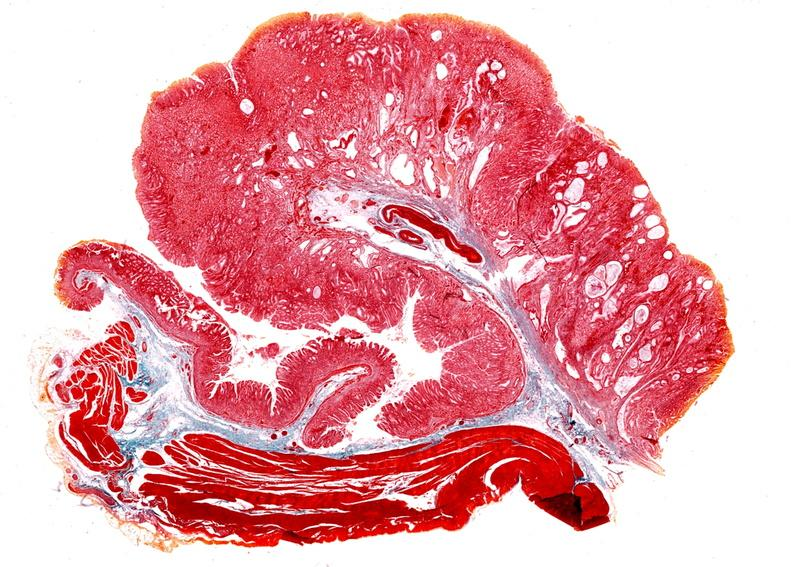does stillborn macerated show stomach, giant rugose hyperplasia?
Answer the question using a single word or phrase. No 